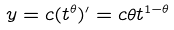<formula> <loc_0><loc_0><loc_500><loc_500>y = c ( t ^ { \theta } ) ^ { \prime } = c \theta t ^ { 1 - \theta }</formula> 